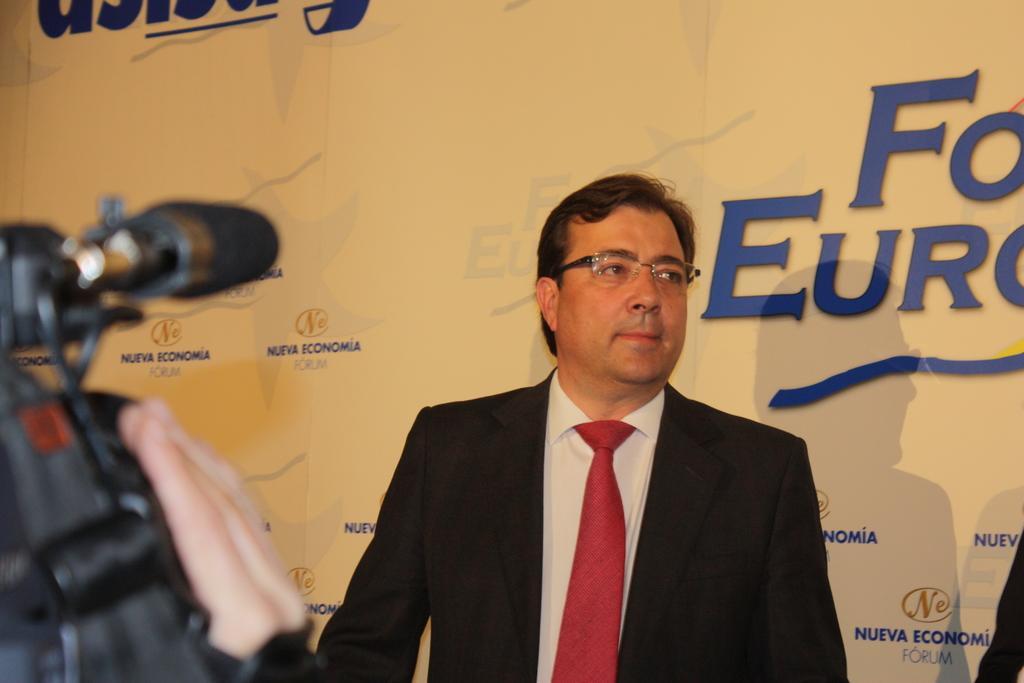Can you describe this image briefly? There is a man standing in front of a banner and in front of the man a camera is focusing on him,it looks like giving an interview. 